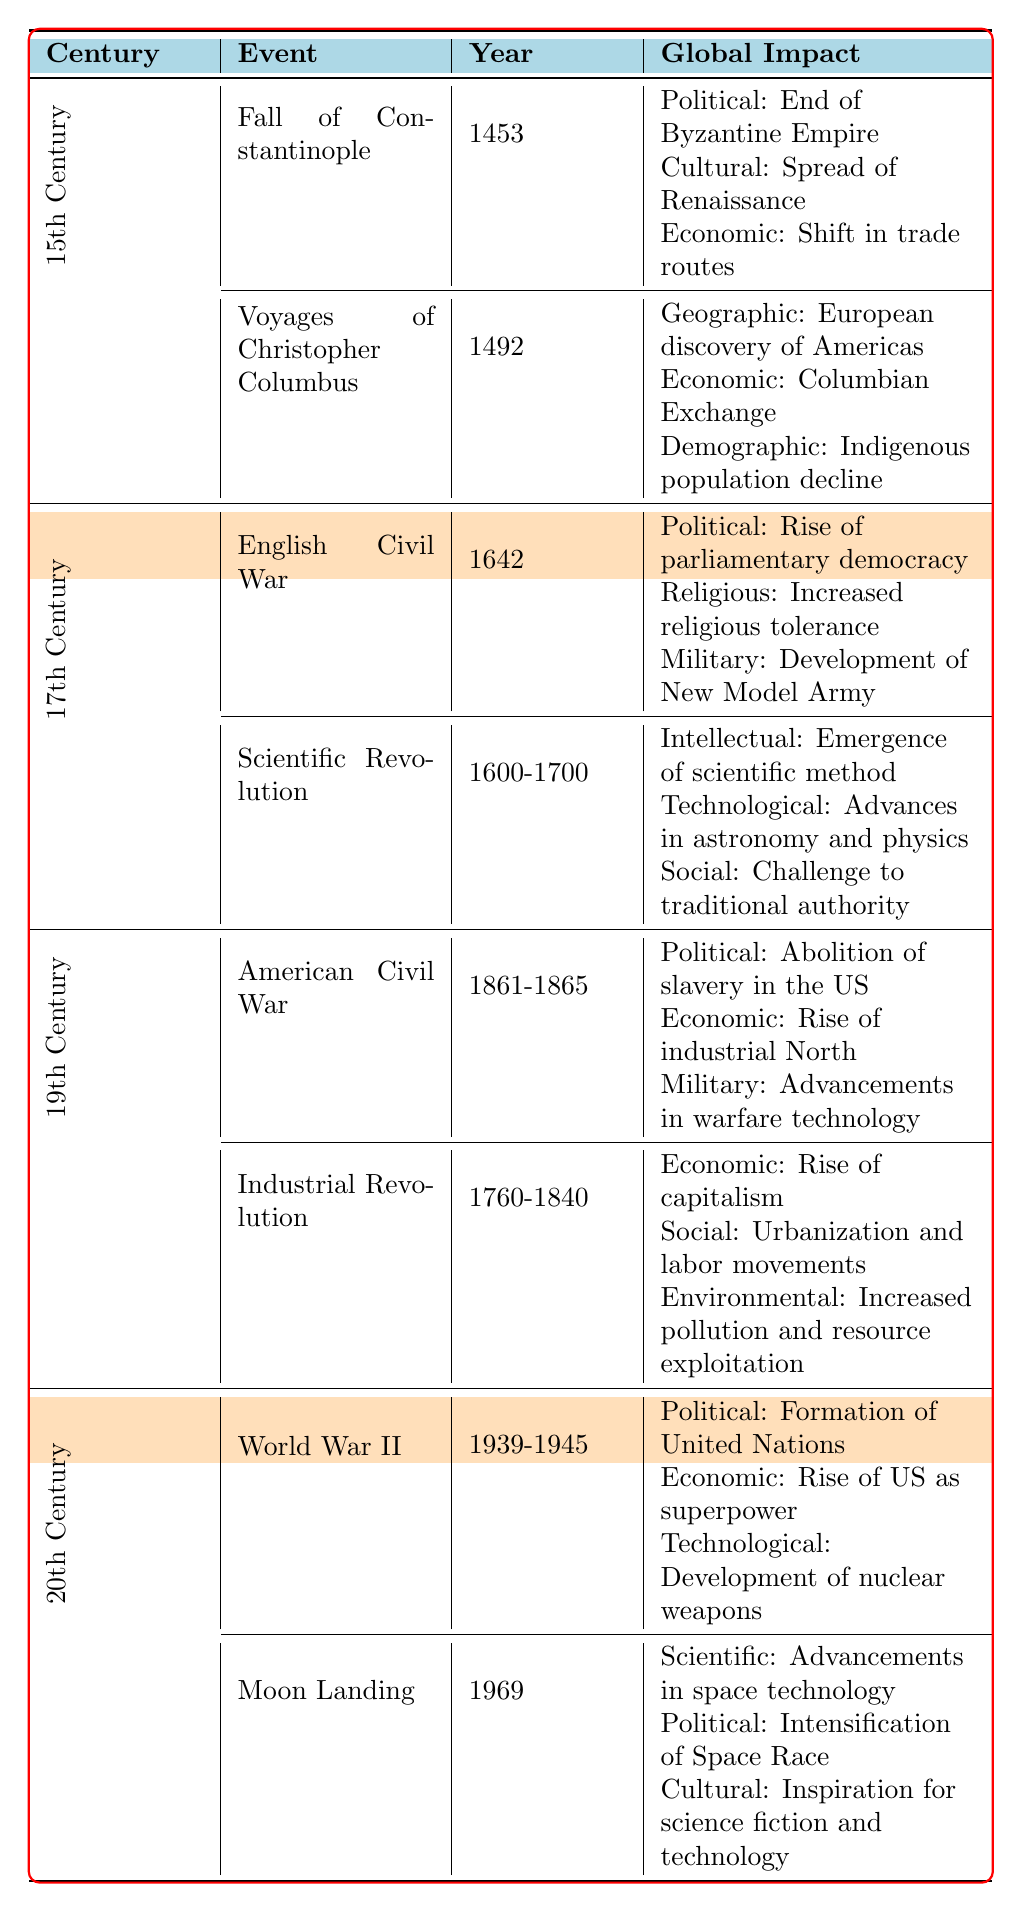What event led to the end of the Byzantine Empire? The table specifies that the Fall of Constantinople occurred in 1453, leading to the end of the Byzantine Empire as a major political entity.
Answer: Fall of Constantinople Which century did the Scientific Revolution occur? The table indicates that the Scientific Revolution took place during the 17th Century, with the timeline specified as 1600-1700.
Answer: 17th Century What was a major economic impact of the American Civil War? According to the table, one of the economic impacts of the American Civil War (1861-1865) was the rise of the industrial North.
Answer: Rise of industrial North In which century did both the Industrial Revolution and the American Civil War happen? The Industrial Revolution occurred in the 19th Century, and the American Civil War also took place in the same century (1861-1865). Therefore, both events happened in the 19th Century.
Answer: 19th Century Did the Moon Landing have any cultural impact according to the table? Yes, the table states that one of the cultural impacts of the Moon Landing in 1969 was the inspiration it provided for science fiction and technology.
Answer: Yes What is the main political impact of World War II according to the table? The table highlights that one of the significant political impacts of World War II (1939-1945) was the formation of the United Nations.
Answer: Formation of United Nations Which event caused a demographic decline of the Indigenous population? The table mentions that the Voyages of Christopher Columbus in 1492 had a demographic impact, leading to the Indigenous population decline.
Answer: Voyages of Christopher Columbus How many major events are listed for the 20th Century? There are two major events listed for the 20th Century: World War II and the Moon Landing.
Answer: 2 What was one technological advancement mentioned due to the Scientific Revolution? The table notes that the Scientific Revolution led to technological advancements in astronomy and physics, among other effects.
Answer: Advances in astronomy and physics Was the rise of capitalism associated with the 19th Century? Yes, as per the table, the Industrial Revolution in the 19th Century is associated with the rise of capitalism as a major economic change.
Answer: Yes 